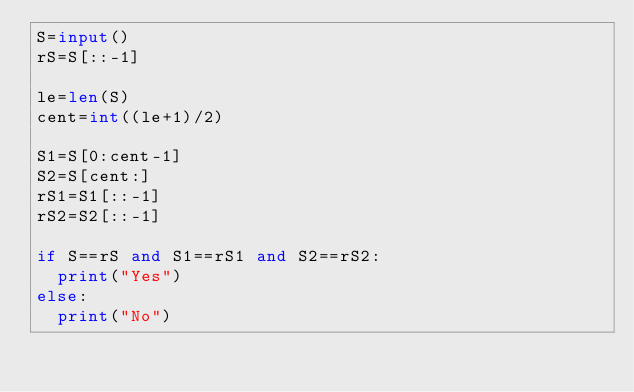Convert code to text. <code><loc_0><loc_0><loc_500><loc_500><_Python_>S=input()
rS=S[::-1]

le=len(S)
cent=int((le+1)/2)

S1=S[0:cent-1]
S2=S[cent:]
rS1=S1[::-1]
rS2=S2[::-1]

if S==rS and S1==rS1 and S2==rS2:
  print("Yes")
else:
  print("No")
</code> 